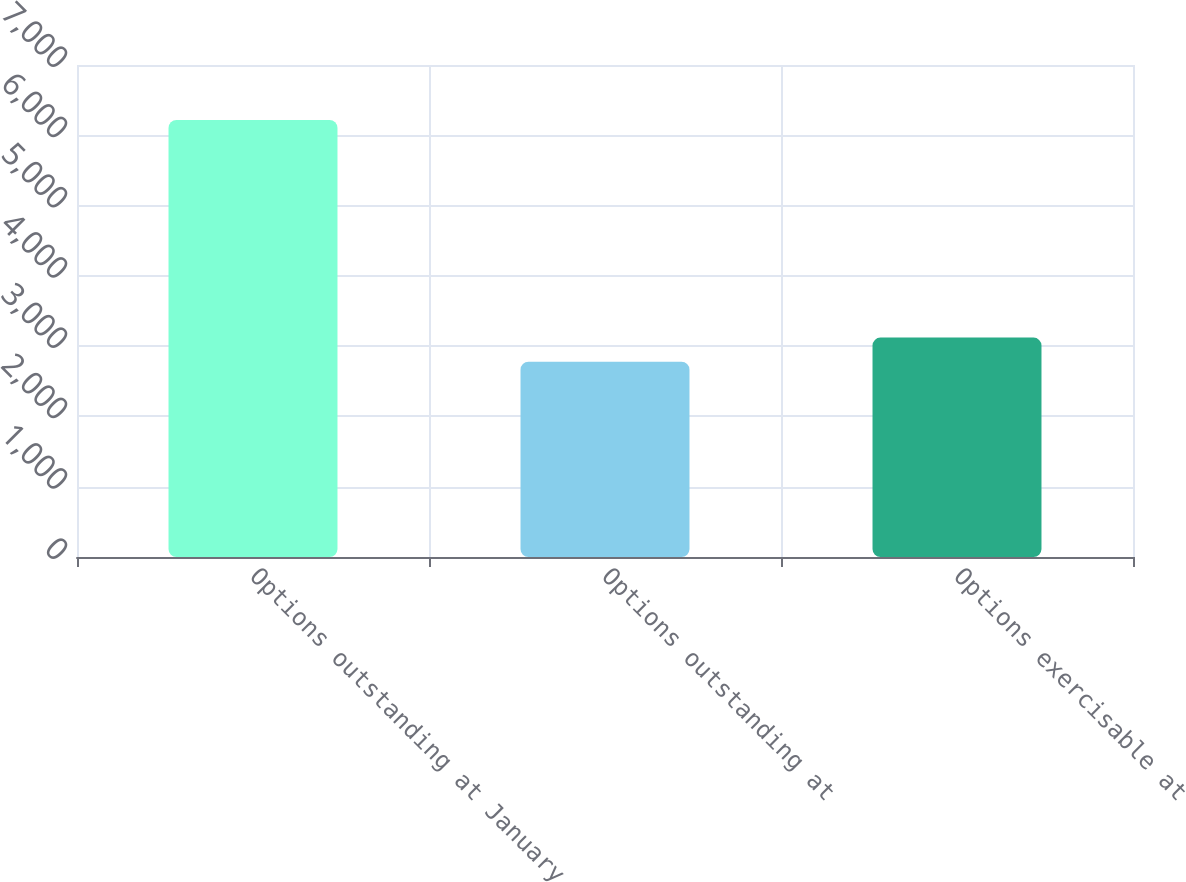Convert chart. <chart><loc_0><loc_0><loc_500><loc_500><bar_chart><fcel>Options outstanding at January<fcel>Options outstanding at<fcel>Options exercisable at<nl><fcel>6218<fcel>2778<fcel>3122<nl></chart> 